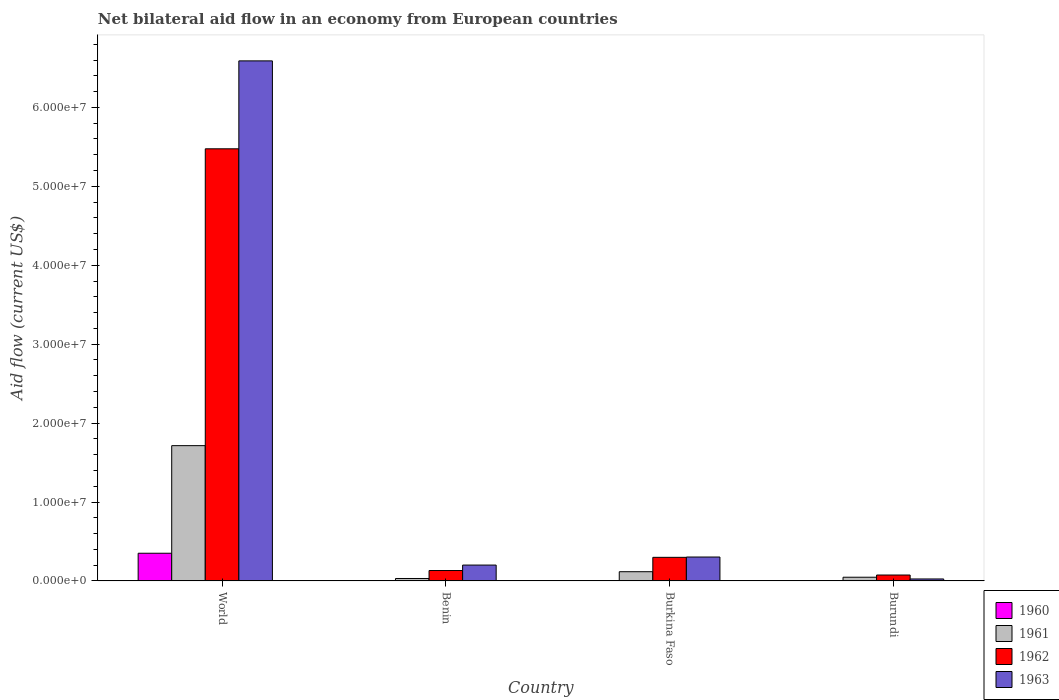Are the number of bars per tick equal to the number of legend labels?
Your response must be concise. Yes. Are the number of bars on each tick of the X-axis equal?
Provide a short and direct response. Yes. How many bars are there on the 4th tick from the left?
Provide a short and direct response. 4. How many bars are there on the 2nd tick from the right?
Ensure brevity in your answer.  4. What is the label of the 3rd group of bars from the left?
Your answer should be compact. Burkina Faso. In how many cases, is the number of bars for a given country not equal to the number of legend labels?
Your response must be concise. 0. What is the net bilateral aid flow in 1960 in Burkina Faso?
Your response must be concise. 10000. Across all countries, what is the maximum net bilateral aid flow in 1962?
Give a very brief answer. 5.48e+07. Across all countries, what is the minimum net bilateral aid flow in 1961?
Your answer should be very brief. 3.10e+05. In which country was the net bilateral aid flow in 1963 minimum?
Keep it short and to the point. Burundi. What is the total net bilateral aid flow in 1963 in the graph?
Provide a short and direct response. 7.12e+07. What is the difference between the net bilateral aid flow in 1961 in Burkina Faso and the net bilateral aid flow in 1960 in Burundi?
Give a very brief answer. 1.16e+06. What is the average net bilateral aid flow in 1961 per country?
Your answer should be compact. 4.77e+06. What is the ratio of the net bilateral aid flow in 1960 in Burundi to that in World?
Your answer should be compact. 0. What is the difference between the highest and the second highest net bilateral aid flow in 1962?
Offer a very short reply. 5.34e+07. What is the difference between the highest and the lowest net bilateral aid flow in 1961?
Make the answer very short. 1.68e+07. In how many countries, is the net bilateral aid flow in 1961 greater than the average net bilateral aid flow in 1961 taken over all countries?
Keep it short and to the point. 1. Is the sum of the net bilateral aid flow in 1962 in Benin and Burundi greater than the maximum net bilateral aid flow in 1960 across all countries?
Your response must be concise. No. What does the 3rd bar from the left in Burundi represents?
Offer a terse response. 1962. What is the difference between two consecutive major ticks on the Y-axis?
Your answer should be compact. 1.00e+07. Are the values on the major ticks of Y-axis written in scientific E-notation?
Offer a very short reply. Yes. Does the graph contain grids?
Provide a short and direct response. No. How many legend labels are there?
Offer a very short reply. 4. How are the legend labels stacked?
Keep it short and to the point. Vertical. What is the title of the graph?
Your answer should be very brief. Net bilateral aid flow in an economy from European countries. What is the Aid flow (current US$) in 1960 in World?
Make the answer very short. 3.51e+06. What is the Aid flow (current US$) in 1961 in World?
Provide a succinct answer. 1.71e+07. What is the Aid flow (current US$) in 1962 in World?
Your answer should be very brief. 5.48e+07. What is the Aid flow (current US$) in 1963 in World?
Your answer should be very brief. 6.59e+07. What is the Aid flow (current US$) of 1962 in Benin?
Provide a short and direct response. 1.32e+06. What is the Aid flow (current US$) of 1963 in Benin?
Provide a succinct answer. 2.01e+06. What is the Aid flow (current US$) in 1960 in Burkina Faso?
Offer a very short reply. 10000. What is the Aid flow (current US$) of 1961 in Burkina Faso?
Keep it short and to the point. 1.17e+06. What is the Aid flow (current US$) in 1962 in Burkina Faso?
Provide a succinct answer. 2.99e+06. What is the Aid flow (current US$) of 1963 in Burkina Faso?
Your answer should be compact. 3.03e+06. What is the Aid flow (current US$) of 1962 in Burundi?
Your answer should be compact. 7.50e+05. What is the Aid flow (current US$) in 1963 in Burundi?
Your answer should be very brief. 2.50e+05. Across all countries, what is the maximum Aid flow (current US$) of 1960?
Your response must be concise. 3.51e+06. Across all countries, what is the maximum Aid flow (current US$) of 1961?
Your answer should be very brief. 1.71e+07. Across all countries, what is the maximum Aid flow (current US$) in 1962?
Ensure brevity in your answer.  5.48e+07. Across all countries, what is the maximum Aid flow (current US$) of 1963?
Give a very brief answer. 6.59e+07. Across all countries, what is the minimum Aid flow (current US$) of 1960?
Your answer should be very brief. 10000. Across all countries, what is the minimum Aid flow (current US$) of 1962?
Offer a terse response. 7.50e+05. Across all countries, what is the minimum Aid flow (current US$) of 1963?
Your response must be concise. 2.50e+05. What is the total Aid flow (current US$) of 1960 in the graph?
Keep it short and to the point. 3.54e+06. What is the total Aid flow (current US$) of 1961 in the graph?
Ensure brevity in your answer.  1.91e+07. What is the total Aid flow (current US$) in 1962 in the graph?
Provide a succinct answer. 5.98e+07. What is the total Aid flow (current US$) of 1963 in the graph?
Offer a terse response. 7.12e+07. What is the difference between the Aid flow (current US$) in 1960 in World and that in Benin?
Provide a short and direct response. 3.50e+06. What is the difference between the Aid flow (current US$) of 1961 in World and that in Benin?
Make the answer very short. 1.68e+07. What is the difference between the Aid flow (current US$) in 1962 in World and that in Benin?
Provide a succinct answer. 5.34e+07. What is the difference between the Aid flow (current US$) in 1963 in World and that in Benin?
Offer a terse response. 6.39e+07. What is the difference between the Aid flow (current US$) in 1960 in World and that in Burkina Faso?
Your response must be concise. 3.50e+06. What is the difference between the Aid flow (current US$) of 1961 in World and that in Burkina Faso?
Make the answer very short. 1.60e+07. What is the difference between the Aid flow (current US$) of 1962 in World and that in Burkina Faso?
Keep it short and to the point. 5.18e+07. What is the difference between the Aid flow (current US$) of 1963 in World and that in Burkina Faso?
Offer a terse response. 6.29e+07. What is the difference between the Aid flow (current US$) in 1960 in World and that in Burundi?
Your response must be concise. 3.50e+06. What is the difference between the Aid flow (current US$) in 1961 in World and that in Burundi?
Your answer should be compact. 1.67e+07. What is the difference between the Aid flow (current US$) in 1962 in World and that in Burundi?
Offer a very short reply. 5.40e+07. What is the difference between the Aid flow (current US$) in 1963 in World and that in Burundi?
Ensure brevity in your answer.  6.56e+07. What is the difference between the Aid flow (current US$) in 1960 in Benin and that in Burkina Faso?
Ensure brevity in your answer.  0. What is the difference between the Aid flow (current US$) in 1961 in Benin and that in Burkina Faso?
Your answer should be compact. -8.60e+05. What is the difference between the Aid flow (current US$) of 1962 in Benin and that in Burkina Faso?
Your answer should be compact. -1.67e+06. What is the difference between the Aid flow (current US$) of 1963 in Benin and that in Burkina Faso?
Offer a terse response. -1.02e+06. What is the difference between the Aid flow (current US$) of 1961 in Benin and that in Burundi?
Provide a short and direct response. -1.60e+05. What is the difference between the Aid flow (current US$) of 1962 in Benin and that in Burundi?
Your answer should be compact. 5.70e+05. What is the difference between the Aid flow (current US$) of 1963 in Benin and that in Burundi?
Provide a short and direct response. 1.76e+06. What is the difference between the Aid flow (current US$) in 1960 in Burkina Faso and that in Burundi?
Offer a terse response. 0. What is the difference between the Aid flow (current US$) of 1962 in Burkina Faso and that in Burundi?
Your response must be concise. 2.24e+06. What is the difference between the Aid flow (current US$) of 1963 in Burkina Faso and that in Burundi?
Keep it short and to the point. 2.78e+06. What is the difference between the Aid flow (current US$) in 1960 in World and the Aid flow (current US$) in 1961 in Benin?
Offer a very short reply. 3.20e+06. What is the difference between the Aid flow (current US$) of 1960 in World and the Aid flow (current US$) of 1962 in Benin?
Offer a terse response. 2.19e+06. What is the difference between the Aid flow (current US$) of 1960 in World and the Aid flow (current US$) of 1963 in Benin?
Make the answer very short. 1.50e+06. What is the difference between the Aid flow (current US$) of 1961 in World and the Aid flow (current US$) of 1962 in Benin?
Give a very brief answer. 1.58e+07. What is the difference between the Aid flow (current US$) in 1961 in World and the Aid flow (current US$) in 1963 in Benin?
Provide a short and direct response. 1.51e+07. What is the difference between the Aid flow (current US$) of 1962 in World and the Aid flow (current US$) of 1963 in Benin?
Provide a short and direct response. 5.27e+07. What is the difference between the Aid flow (current US$) in 1960 in World and the Aid flow (current US$) in 1961 in Burkina Faso?
Provide a succinct answer. 2.34e+06. What is the difference between the Aid flow (current US$) in 1960 in World and the Aid flow (current US$) in 1962 in Burkina Faso?
Your answer should be compact. 5.20e+05. What is the difference between the Aid flow (current US$) of 1961 in World and the Aid flow (current US$) of 1962 in Burkina Faso?
Give a very brief answer. 1.42e+07. What is the difference between the Aid flow (current US$) in 1961 in World and the Aid flow (current US$) in 1963 in Burkina Faso?
Your answer should be very brief. 1.41e+07. What is the difference between the Aid flow (current US$) in 1962 in World and the Aid flow (current US$) in 1963 in Burkina Faso?
Give a very brief answer. 5.17e+07. What is the difference between the Aid flow (current US$) of 1960 in World and the Aid flow (current US$) of 1961 in Burundi?
Provide a short and direct response. 3.04e+06. What is the difference between the Aid flow (current US$) of 1960 in World and the Aid flow (current US$) of 1962 in Burundi?
Ensure brevity in your answer.  2.76e+06. What is the difference between the Aid flow (current US$) of 1960 in World and the Aid flow (current US$) of 1963 in Burundi?
Offer a very short reply. 3.26e+06. What is the difference between the Aid flow (current US$) of 1961 in World and the Aid flow (current US$) of 1962 in Burundi?
Offer a very short reply. 1.64e+07. What is the difference between the Aid flow (current US$) of 1961 in World and the Aid flow (current US$) of 1963 in Burundi?
Give a very brief answer. 1.69e+07. What is the difference between the Aid flow (current US$) in 1962 in World and the Aid flow (current US$) in 1963 in Burundi?
Your response must be concise. 5.45e+07. What is the difference between the Aid flow (current US$) of 1960 in Benin and the Aid flow (current US$) of 1961 in Burkina Faso?
Keep it short and to the point. -1.16e+06. What is the difference between the Aid flow (current US$) in 1960 in Benin and the Aid flow (current US$) in 1962 in Burkina Faso?
Offer a terse response. -2.98e+06. What is the difference between the Aid flow (current US$) in 1960 in Benin and the Aid flow (current US$) in 1963 in Burkina Faso?
Offer a terse response. -3.02e+06. What is the difference between the Aid flow (current US$) of 1961 in Benin and the Aid flow (current US$) of 1962 in Burkina Faso?
Provide a short and direct response. -2.68e+06. What is the difference between the Aid flow (current US$) in 1961 in Benin and the Aid flow (current US$) in 1963 in Burkina Faso?
Offer a terse response. -2.72e+06. What is the difference between the Aid flow (current US$) of 1962 in Benin and the Aid flow (current US$) of 1963 in Burkina Faso?
Provide a succinct answer. -1.71e+06. What is the difference between the Aid flow (current US$) in 1960 in Benin and the Aid flow (current US$) in 1961 in Burundi?
Offer a terse response. -4.60e+05. What is the difference between the Aid flow (current US$) of 1960 in Benin and the Aid flow (current US$) of 1962 in Burundi?
Your answer should be compact. -7.40e+05. What is the difference between the Aid flow (current US$) in 1961 in Benin and the Aid flow (current US$) in 1962 in Burundi?
Offer a very short reply. -4.40e+05. What is the difference between the Aid flow (current US$) of 1962 in Benin and the Aid flow (current US$) of 1963 in Burundi?
Provide a succinct answer. 1.07e+06. What is the difference between the Aid flow (current US$) in 1960 in Burkina Faso and the Aid flow (current US$) in 1961 in Burundi?
Give a very brief answer. -4.60e+05. What is the difference between the Aid flow (current US$) of 1960 in Burkina Faso and the Aid flow (current US$) of 1962 in Burundi?
Keep it short and to the point. -7.40e+05. What is the difference between the Aid flow (current US$) in 1960 in Burkina Faso and the Aid flow (current US$) in 1963 in Burundi?
Keep it short and to the point. -2.40e+05. What is the difference between the Aid flow (current US$) of 1961 in Burkina Faso and the Aid flow (current US$) of 1962 in Burundi?
Provide a short and direct response. 4.20e+05. What is the difference between the Aid flow (current US$) in 1961 in Burkina Faso and the Aid flow (current US$) in 1963 in Burundi?
Offer a terse response. 9.20e+05. What is the difference between the Aid flow (current US$) of 1962 in Burkina Faso and the Aid flow (current US$) of 1963 in Burundi?
Make the answer very short. 2.74e+06. What is the average Aid flow (current US$) in 1960 per country?
Give a very brief answer. 8.85e+05. What is the average Aid flow (current US$) of 1961 per country?
Ensure brevity in your answer.  4.77e+06. What is the average Aid flow (current US$) in 1962 per country?
Ensure brevity in your answer.  1.50e+07. What is the average Aid flow (current US$) in 1963 per country?
Offer a terse response. 1.78e+07. What is the difference between the Aid flow (current US$) in 1960 and Aid flow (current US$) in 1961 in World?
Keep it short and to the point. -1.36e+07. What is the difference between the Aid flow (current US$) of 1960 and Aid flow (current US$) of 1962 in World?
Your answer should be very brief. -5.12e+07. What is the difference between the Aid flow (current US$) in 1960 and Aid flow (current US$) in 1963 in World?
Give a very brief answer. -6.24e+07. What is the difference between the Aid flow (current US$) in 1961 and Aid flow (current US$) in 1962 in World?
Provide a succinct answer. -3.76e+07. What is the difference between the Aid flow (current US$) of 1961 and Aid flow (current US$) of 1963 in World?
Your response must be concise. -4.88e+07. What is the difference between the Aid flow (current US$) of 1962 and Aid flow (current US$) of 1963 in World?
Your answer should be very brief. -1.11e+07. What is the difference between the Aid flow (current US$) of 1960 and Aid flow (current US$) of 1961 in Benin?
Provide a succinct answer. -3.00e+05. What is the difference between the Aid flow (current US$) of 1960 and Aid flow (current US$) of 1962 in Benin?
Make the answer very short. -1.31e+06. What is the difference between the Aid flow (current US$) of 1961 and Aid flow (current US$) of 1962 in Benin?
Your response must be concise. -1.01e+06. What is the difference between the Aid flow (current US$) in 1961 and Aid flow (current US$) in 1963 in Benin?
Your response must be concise. -1.70e+06. What is the difference between the Aid flow (current US$) of 1962 and Aid flow (current US$) of 1963 in Benin?
Offer a terse response. -6.90e+05. What is the difference between the Aid flow (current US$) in 1960 and Aid flow (current US$) in 1961 in Burkina Faso?
Provide a short and direct response. -1.16e+06. What is the difference between the Aid flow (current US$) of 1960 and Aid flow (current US$) of 1962 in Burkina Faso?
Ensure brevity in your answer.  -2.98e+06. What is the difference between the Aid flow (current US$) of 1960 and Aid flow (current US$) of 1963 in Burkina Faso?
Ensure brevity in your answer.  -3.02e+06. What is the difference between the Aid flow (current US$) in 1961 and Aid flow (current US$) in 1962 in Burkina Faso?
Offer a terse response. -1.82e+06. What is the difference between the Aid flow (current US$) of 1961 and Aid flow (current US$) of 1963 in Burkina Faso?
Your response must be concise. -1.86e+06. What is the difference between the Aid flow (current US$) of 1960 and Aid flow (current US$) of 1961 in Burundi?
Your response must be concise. -4.60e+05. What is the difference between the Aid flow (current US$) in 1960 and Aid flow (current US$) in 1962 in Burundi?
Your answer should be very brief. -7.40e+05. What is the difference between the Aid flow (current US$) in 1960 and Aid flow (current US$) in 1963 in Burundi?
Your answer should be very brief. -2.40e+05. What is the difference between the Aid flow (current US$) in 1961 and Aid flow (current US$) in 1962 in Burundi?
Offer a very short reply. -2.80e+05. What is the difference between the Aid flow (current US$) in 1961 and Aid flow (current US$) in 1963 in Burundi?
Your answer should be very brief. 2.20e+05. What is the ratio of the Aid flow (current US$) in 1960 in World to that in Benin?
Offer a terse response. 351. What is the ratio of the Aid flow (current US$) of 1961 in World to that in Benin?
Ensure brevity in your answer.  55.29. What is the ratio of the Aid flow (current US$) of 1962 in World to that in Benin?
Give a very brief answer. 41.48. What is the ratio of the Aid flow (current US$) in 1963 in World to that in Benin?
Keep it short and to the point. 32.78. What is the ratio of the Aid flow (current US$) in 1960 in World to that in Burkina Faso?
Give a very brief answer. 351. What is the ratio of the Aid flow (current US$) of 1961 in World to that in Burkina Faso?
Your answer should be very brief. 14.65. What is the ratio of the Aid flow (current US$) of 1962 in World to that in Burkina Faso?
Offer a very short reply. 18.31. What is the ratio of the Aid flow (current US$) of 1963 in World to that in Burkina Faso?
Ensure brevity in your answer.  21.75. What is the ratio of the Aid flow (current US$) in 1960 in World to that in Burundi?
Provide a short and direct response. 351. What is the ratio of the Aid flow (current US$) in 1961 in World to that in Burundi?
Your response must be concise. 36.47. What is the ratio of the Aid flow (current US$) of 1963 in World to that in Burundi?
Provide a short and direct response. 263.56. What is the ratio of the Aid flow (current US$) of 1960 in Benin to that in Burkina Faso?
Offer a very short reply. 1. What is the ratio of the Aid flow (current US$) of 1961 in Benin to that in Burkina Faso?
Your answer should be compact. 0.27. What is the ratio of the Aid flow (current US$) in 1962 in Benin to that in Burkina Faso?
Provide a succinct answer. 0.44. What is the ratio of the Aid flow (current US$) of 1963 in Benin to that in Burkina Faso?
Give a very brief answer. 0.66. What is the ratio of the Aid flow (current US$) in 1961 in Benin to that in Burundi?
Offer a terse response. 0.66. What is the ratio of the Aid flow (current US$) in 1962 in Benin to that in Burundi?
Give a very brief answer. 1.76. What is the ratio of the Aid flow (current US$) of 1963 in Benin to that in Burundi?
Offer a terse response. 8.04. What is the ratio of the Aid flow (current US$) of 1960 in Burkina Faso to that in Burundi?
Offer a terse response. 1. What is the ratio of the Aid flow (current US$) of 1961 in Burkina Faso to that in Burundi?
Ensure brevity in your answer.  2.49. What is the ratio of the Aid flow (current US$) in 1962 in Burkina Faso to that in Burundi?
Provide a succinct answer. 3.99. What is the ratio of the Aid flow (current US$) in 1963 in Burkina Faso to that in Burundi?
Offer a very short reply. 12.12. What is the difference between the highest and the second highest Aid flow (current US$) in 1960?
Keep it short and to the point. 3.50e+06. What is the difference between the highest and the second highest Aid flow (current US$) in 1961?
Provide a succinct answer. 1.60e+07. What is the difference between the highest and the second highest Aid flow (current US$) of 1962?
Give a very brief answer. 5.18e+07. What is the difference between the highest and the second highest Aid flow (current US$) of 1963?
Ensure brevity in your answer.  6.29e+07. What is the difference between the highest and the lowest Aid flow (current US$) of 1960?
Your answer should be very brief. 3.50e+06. What is the difference between the highest and the lowest Aid flow (current US$) of 1961?
Provide a succinct answer. 1.68e+07. What is the difference between the highest and the lowest Aid flow (current US$) of 1962?
Keep it short and to the point. 5.40e+07. What is the difference between the highest and the lowest Aid flow (current US$) of 1963?
Ensure brevity in your answer.  6.56e+07. 